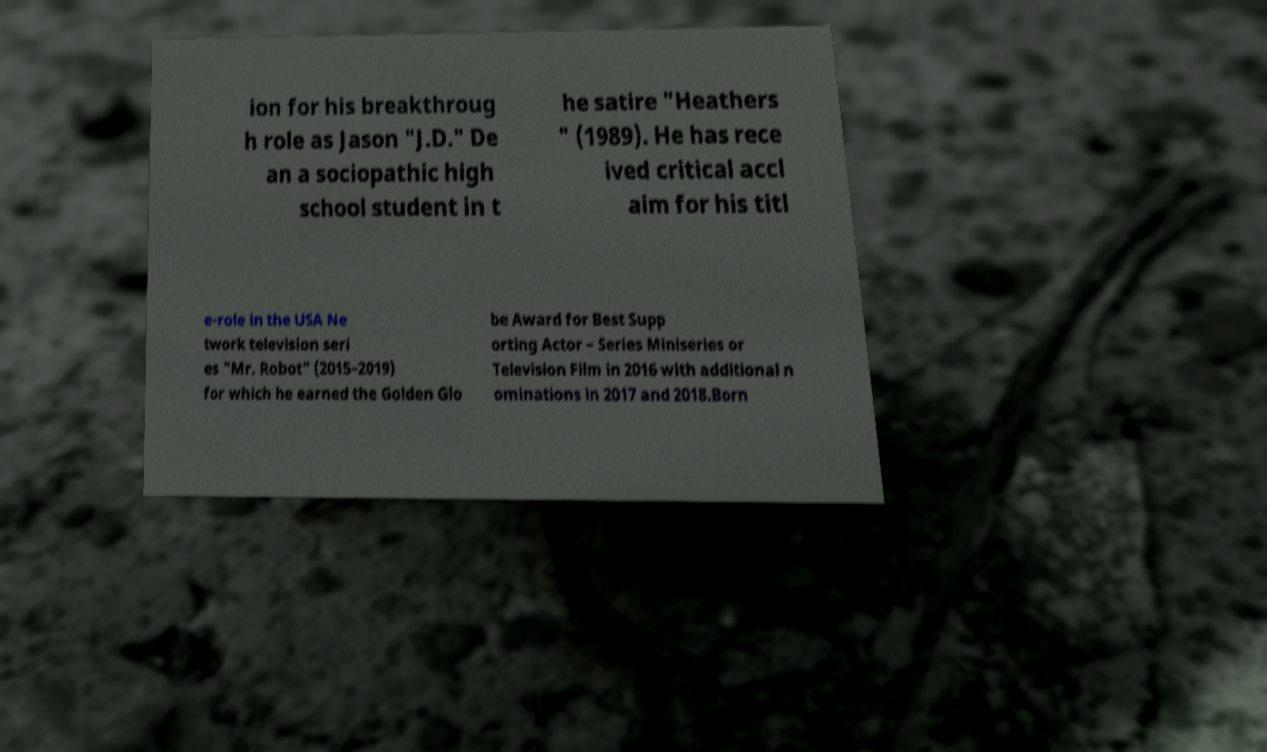Please identify and transcribe the text found in this image. ion for his breakthroug h role as Jason "J.D." De an a sociopathic high school student in t he satire "Heathers " (1989). He has rece ived critical accl aim for his titl e-role in the USA Ne twork television seri es "Mr. Robot" (2015–2019) for which he earned the Golden Glo be Award for Best Supp orting Actor – Series Miniseries or Television Film in 2016 with additional n ominations in 2017 and 2018.Born 